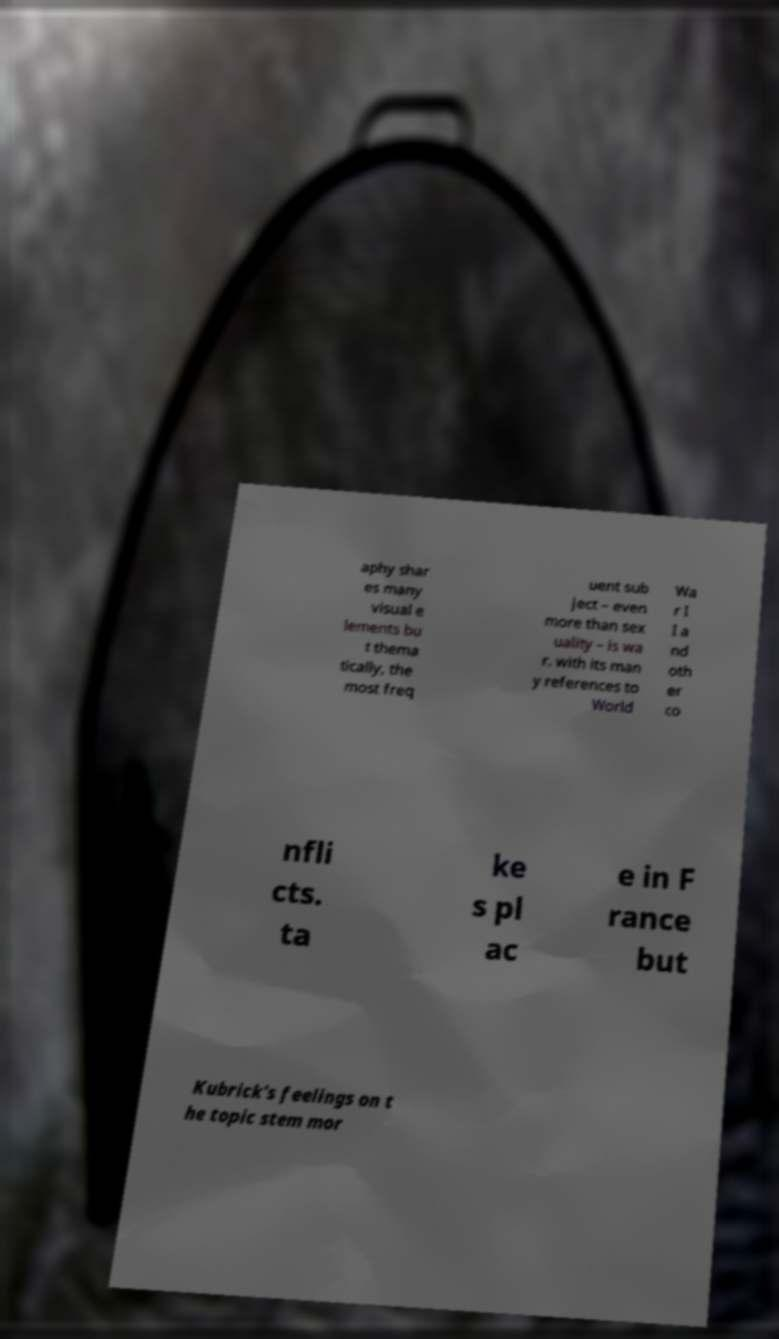Could you extract and type out the text from this image? aphy shar es many visual e lements bu t thema tically, the most freq uent sub ject – even more than sex uality – is wa r. with its man y references to World Wa r I I a nd oth er co nfli cts. ta ke s pl ac e in F rance but Kubrick's feelings on t he topic stem mor 